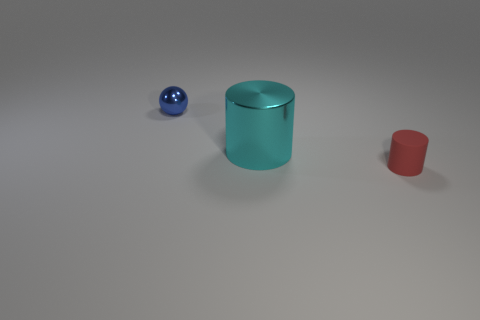Are there any red cylinders that have the same size as the blue shiny thing?
Offer a very short reply. Yes. Is the number of small matte objects greater than the number of tiny purple rubber spheres?
Make the answer very short. Yes. There is a metallic thing that is to the left of the big cyan shiny cylinder; is its size the same as the metal thing to the right of the blue metallic thing?
Offer a terse response. No. How many things are behind the tiny rubber object and to the right of the blue thing?
Ensure brevity in your answer.  1. What is the color of the other large object that is the same shape as the red matte object?
Offer a terse response. Cyan. Is the number of blue shiny spheres less than the number of things?
Offer a terse response. Yes. There is a red matte cylinder; does it have the same size as the object that is on the left side of the large cyan cylinder?
Your answer should be very brief. Yes. There is a cylinder that is behind the cylinder that is in front of the shiny cylinder; what color is it?
Your answer should be compact. Cyan. How many things are either metallic things that are on the right side of the small blue shiny ball or cylinders on the left side of the matte thing?
Give a very brief answer. 1. Does the rubber cylinder have the same size as the blue ball?
Give a very brief answer. Yes. 